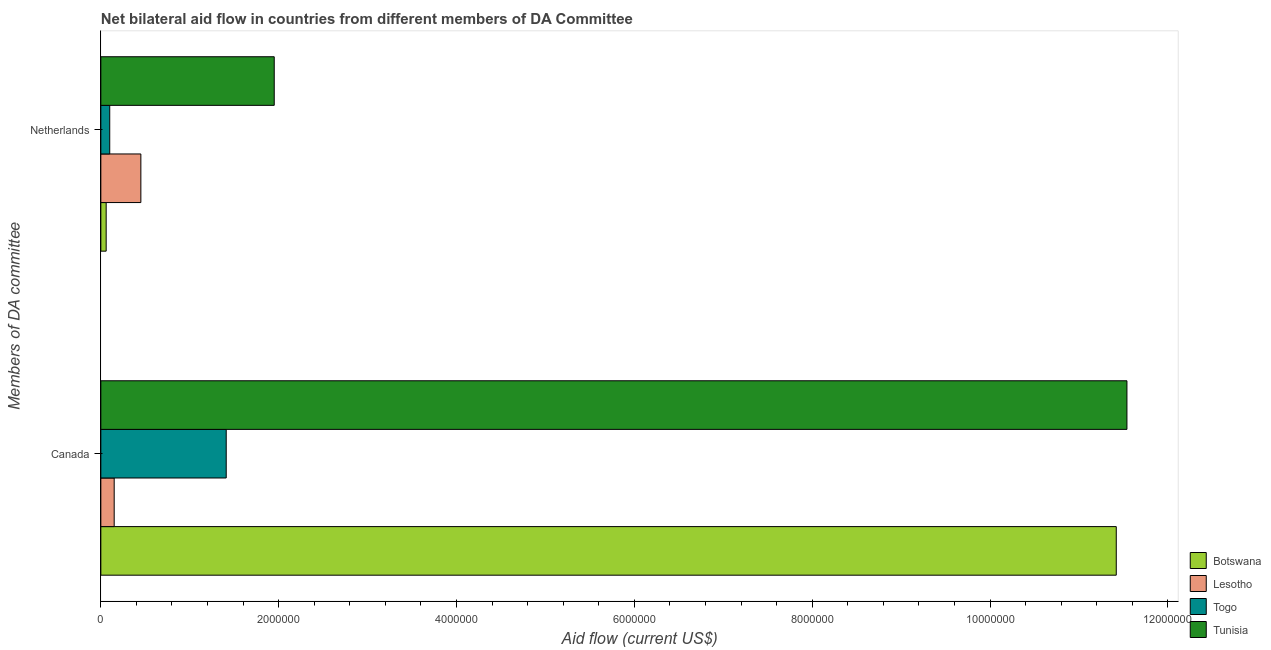Are the number of bars per tick equal to the number of legend labels?
Your answer should be compact. Yes. How many bars are there on the 1st tick from the top?
Your response must be concise. 4. How many bars are there on the 2nd tick from the bottom?
Your answer should be very brief. 4. What is the amount of aid given by netherlands in Lesotho?
Keep it short and to the point. 4.50e+05. Across all countries, what is the maximum amount of aid given by netherlands?
Provide a short and direct response. 1.95e+06. Across all countries, what is the minimum amount of aid given by netherlands?
Offer a very short reply. 6.00e+04. In which country was the amount of aid given by canada maximum?
Offer a terse response. Tunisia. In which country was the amount of aid given by netherlands minimum?
Give a very brief answer. Botswana. What is the total amount of aid given by netherlands in the graph?
Keep it short and to the point. 2.56e+06. What is the difference between the amount of aid given by canada in Tunisia and that in Togo?
Make the answer very short. 1.01e+07. What is the difference between the amount of aid given by canada in Togo and the amount of aid given by netherlands in Botswana?
Your response must be concise. 1.35e+06. What is the average amount of aid given by netherlands per country?
Offer a very short reply. 6.40e+05. What is the difference between the amount of aid given by canada and amount of aid given by netherlands in Togo?
Your answer should be compact. 1.31e+06. What is the ratio of the amount of aid given by canada in Botswana to that in Tunisia?
Make the answer very short. 0.99. What does the 4th bar from the top in Netherlands represents?
Your response must be concise. Botswana. What does the 1st bar from the bottom in Canada represents?
Your answer should be very brief. Botswana. How many bars are there?
Offer a very short reply. 8. Are all the bars in the graph horizontal?
Give a very brief answer. Yes. How many countries are there in the graph?
Your answer should be very brief. 4. What is the difference between two consecutive major ticks on the X-axis?
Provide a short and direct response. 2.00e+06. Does the graph contain grids?
Your answer should be compact. No. How many legend labels are there?
Provide a succinct answer. 4. How are the legend labels stacked?
Make the answer very short. Vertical. What is the title of the graph?
Offer a terse response. Net bilateral aid flow in countries from different members of DA Committee. What is the label or title of the X-axis?
Your answer should be very brief. Aid flow (current US$). What is the label or title of the Y-axis?
Provide a succinct answer. Members of DA committee. What is the Aid flow (current US$) in Botswana in Canada?
Provide a succinct answer. 1.14e+07. What is the Aid flow (current US$) in Lesotho in Canada?
Your answer should be very brief. 1.50e+05. What is the Aid flow (current US$) of Togo in Canada?
Keep it short and to the point. 1.41e+06. What is the Aid flow (current US$) in Tunisia in Canada?
Your response must be concise. 1.15e+07. What is the Aid flow (current US$) in Lesotho in Netherlands?
Offer a terse response. 4.50e+05. What is the Aid flow (current US$) of Tunisia in Netherlands?
Ensure brevity in your answer.  1.95e+06. Across all Members of DA committee, what is the maximum Aid flow (current US$) in Botswana?
Your answer should be very brief. 1.14e+07. Across all Members of DA committee, what is the maximum Aid flow (current US$) in Togo?
Your answer should be very brief. 1.41e+06. Across all Members of DA committee, what is the maximum Aid flow (current US$) in Tunisia?
Ensure brevity in your answer.  1.15e+07. Across all Members of DA committee, what is the minimum Aid flow (current US$) in Botswana?
Your answer should be compact. 6.00e+04. Across all Members of DA committee, what is the minimum Aid flow (current US$) in Lesotho?
Give a very brief answer. 1.50e+05. Across all Members of DA committee, what is the minimum Aid flow (current US$) of Togo?
Give a very brief answer. 1.00e+05. Across all Members of DA committee, what is the minimum Aid flow (current US$) in Tunisia?
Offer a very short reply. 1.95e+06. What is the total Aid flow (current US$) of Botswana in the graph?
Provide a short and direct response. 1.15e+07. What is the total Aid flow (current US$) in Lesotho in the graph?
Offer a very short reply. 6.00e+05. What is the total Aid flow (current US$) in Togo in the graph?
Give a very brief answer. 1.51e+06. What is the total Aid flow (current US$) in Tunisia in the graph?
Offer a very short reply. 1.35e+07. What is the difference between the Aid flow (current US$) in Botswana in Canada and that in Netherlands?
Provide a short and direct response. 1.14e+07. What is the difference between the Aid flow (current US$) of Lesotho in Canada and that in Netherlands?
Make the answer very short. -3.00e+05. What is the difference between the Aid flow (current US$) in Togo in Canada and that in Netherlands?
Offer a very short reply. 1.31e+06. What is the difference between the Aid flow (current US$) of Tunisia in Canada and that in Netherlands?
Your answer should be very brief. 9.59e+06. What is the difference between the Aid flow (current US$) of Botswana in Canada and the Aid flow (current US$) of Lesotho in Netherlands?
Provide a succinct answer. 1.10e+07. What is the difference between the Aid flow (current US$) of Botswana in Canada and the Aid flow (current US$) of Togo in Netherlands?
Give a very brief answer. 1.13e+07. What is the difference between the Aid flow (current US$) in Botswana in Canada and the Aid flow (current US$) in Tunisia in Netherlands?
Provide a short and direct response. 9.47e+06. What is the difference between the Aid flow (current US$) in Lesotho in Canada and the Aid flow (current US$) in Togo in Netherlands?
Offer a terse response. 5.00e+04. What is the difference between the Aid flow (current US$) of Lesotho in Canada and the Aid flow (current US$) of Tunisia in Netherlands?
Offer a terse response. -1.80e+06. What is the difference between the Aid flow (current US$) of Togo in Canada and the Aid flow (current US$) of Tunisia in Netherlands?
Provide a short and direct response. -5.40e+05. What is the average Aid flow (current US$) of Botswana per Members of DA committee?
Ensure brevity in your answer.  5.74e+06. What is the average Aid flow (current US$) of Lesotho per Members of DA committee?
Your response must be concise. 3.00e+05. What is the average Aid flow (current US$) in Togo per Members of DA committee?
Your answer should be very brief. 7.55e+05. What is the average Aid flow (current US$) in Tunisia per Members of DA committee?
Offer a terse response. 6.74e+06. What is the difference between the Aid flow (current US$) in Botswana and Aid flow (current US$) in Lesotho in Canada?
Your answer should be very brief. 1.13e+07. What is the difference between the Aid flow (current US$) of Botswana and Aid flow (current US$) of Togo in Canada?
Provide a succinct answer. 1.00e+07. What is the difference between the Aid flow (current US$) in Botswana and Aid flow (current US$) in Tunisia in Canada?
Your answer should be very brief. -1.20e+05. What is the difference between the Aid flow (current US$) in Lesotho and Aid flow (current US$) in Togo in Canada?
Keep it short and to the point. -1.26e+06. What is the difference between the Aid flow (current US$) in Lesotho and Aid flow (current US$) in Tunisia in Canada?
Your response must be concise. -1.14e+07. What is the difference between the Aid flow (current US$) of Togo and Aid flow (current US$) of Tunisia in Canada?
Ensure brevity in your answer.  -1.01e+07. What is the difference between the Aid flow (current US$) of Botswana and Aid flow (current US$) of Lesotho in Netherlands?
Your answer should be compact. -3.90e+05. What is the difference between the Aid flow (current US$) in Botswana and Aid flow (current US$) in Tunisia in Netherlands?
Keep it short and to the point. -1.89e+06. What is the difference between the Aid flow (current US$) of Lesotho and Aid flow (current US$) of Togo in Netherlands?
Offer a very short reply. 3.50e+05. What is the difference between the Aid flow (current US$) of Lesotho and Aid flow (current US$) of Tunisia in Netherlands?
Your response must be concise. -1.50e+06. What is the difference between the Aid flow (current US$) of Togo and Aid flow (current US$) of Tunisia in Netherlands?
Your answer should be compact. -1.85e+06. What is the ratio of the Aid flow (current US$) in Botswana in Canada to that in Netherlands?
Ensure brevity in your answer.  190.33. What is the ratio of the Aid flow (current US$) of Tunisia in Canada to that in Netherlands?
Your response must be concise. 5.92. What is the difference between the highest and the second highest Aid flow (current US$) of Botswana?
Keep it short and to the point. 1.14e+07. What is the difference between the highest and the second highest Aid flow (current US$) in Lesotho?
Give a very brief answer. 3.00e+05. What is the difference between the highest and the second highest Aid flow (current US$) of Togo?
Make the answer very short. 1.31e+06. What is the difference between the highest and the second highest Aid flow (current US$) of Tunisia?
Offer a very short reply. 9.59e+06. What is the difference between the highest and the lowest Aid flow (current US$) of Botswana?
Offer a terse response. 1.14e+07. What is the difference between the highest and the lowest Aid flow (current US$) in Lesotho?
Give a very brief answer. 3.00e+05. What is the difference between the highest and the lowest Aid flow (current US$) of Togo?
Ensure brevity in your answer.  1.31e+06. What is the difference between the highest and the lowest Aid flow (current US$) in Tunisia?
Ensure brevity in your answer.  9.59e+06. 